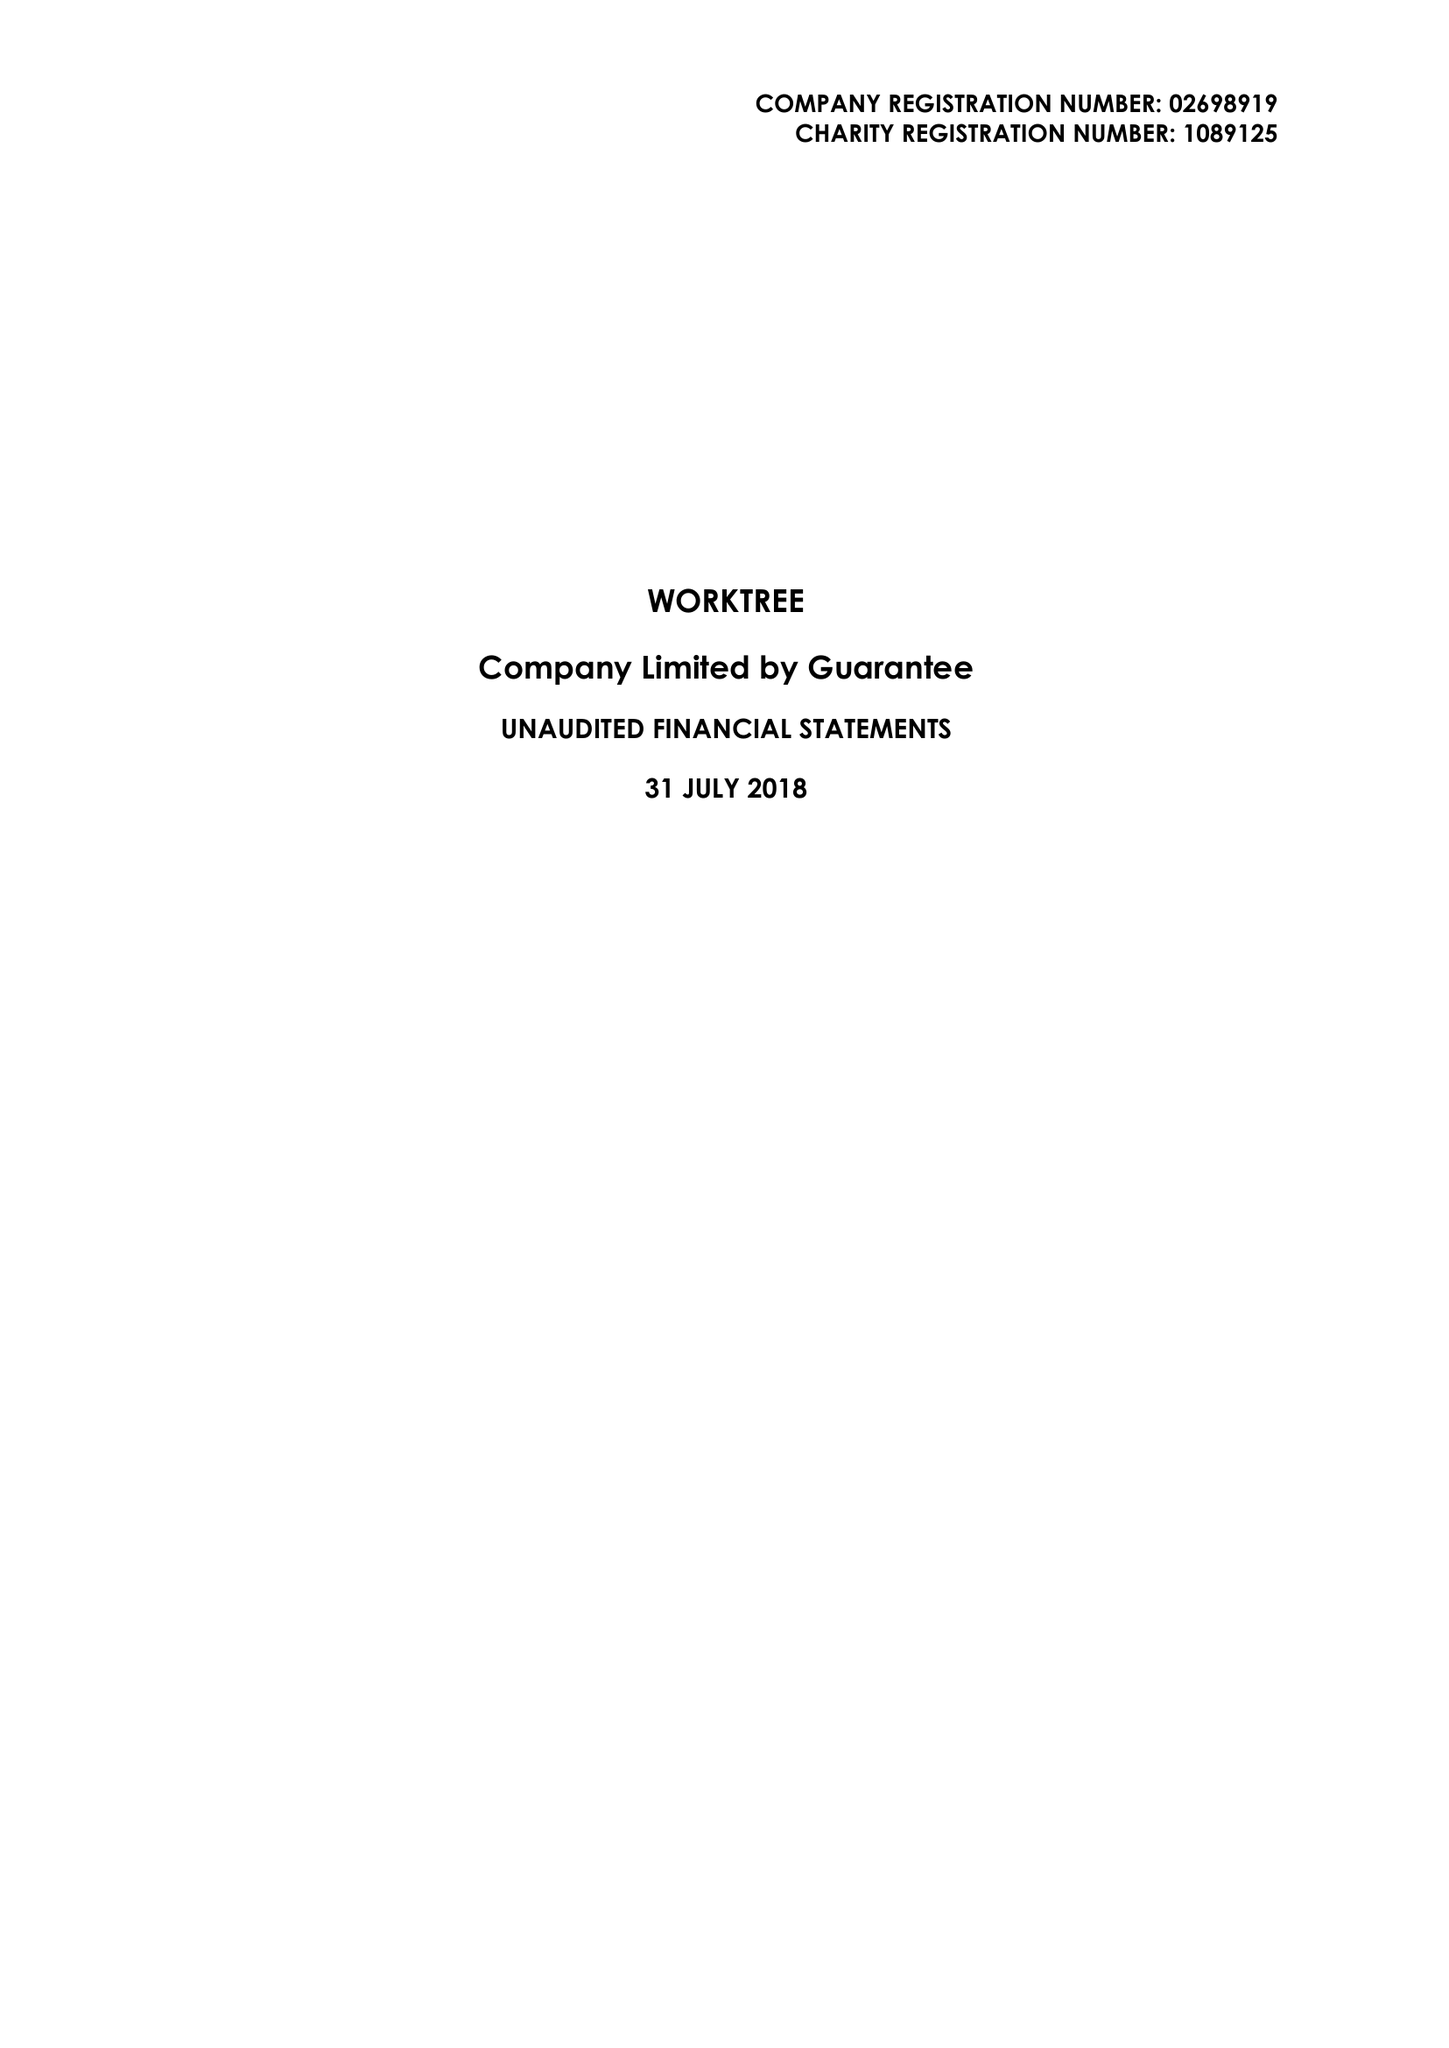What is the value for the address__street_line?
Answer the question using a single word or phrase. 28-29 CLARKE ROAD 